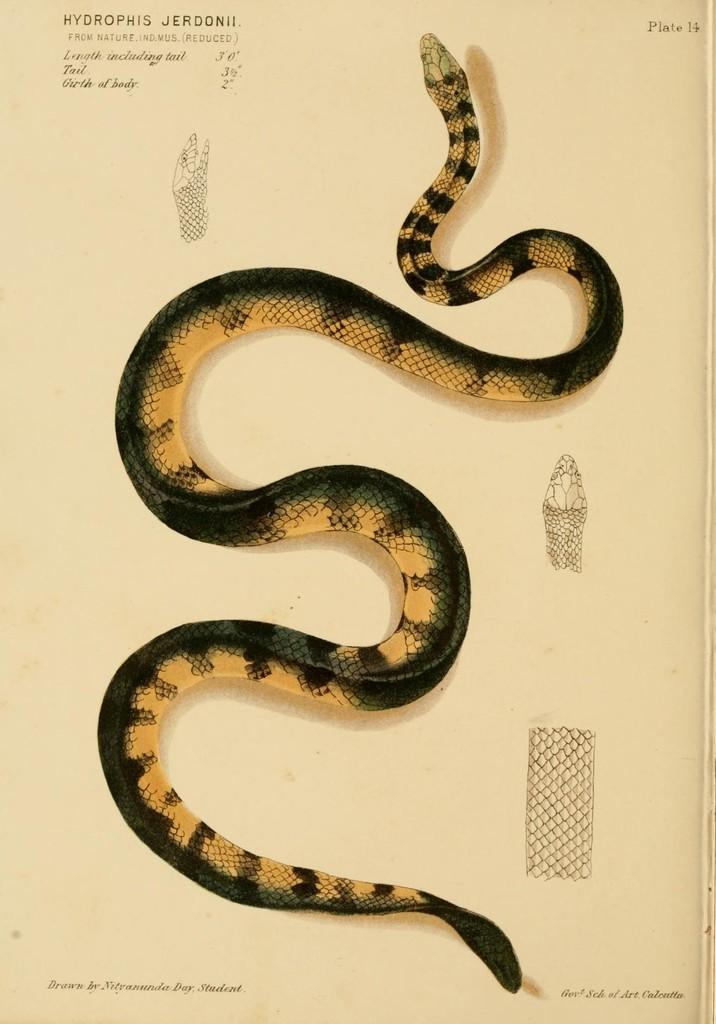What is the main object in the image? The image contains a paper. What can be seen on the paper? There are photos of a snake on the paper. Are there any other elements on the paper besides the snake photos? Yes, there are words and numbers on the paper. Can you tell me how many kittens are playing with a ball of oil in the image? There are no kittens or balls of oil present in the image; it features a paper with snake photos, words, and numbers. 